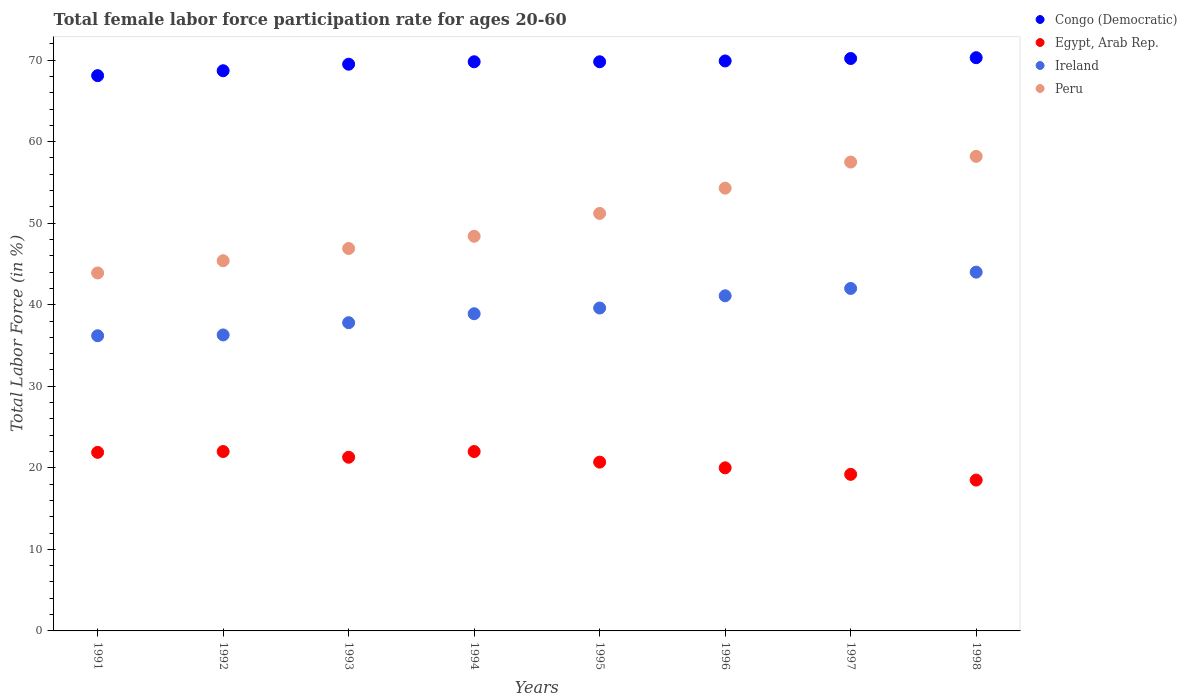How many different coloured dotlines are there?
Make the answer very short. 4. Is the number of dotlines equal to the number of legend labels?
Ensure brevity in your answer.  Yes. What is the female labor force participation rate in Ireland in 1995?
Your answer should be compact. 39.6. Across all years, what is the maximum female labor force participation rate in Congo (Democratic)?
Ensure brevity in your answer.  70.3. Across all years, what is the minimum female labor force participation rate in Congo (Democratic)?
Your response must be concise. 68.1. In which year was the female labor force participation rate in Congo (Democratic) maximum?
Offer a terse response. 1998. In which year was the female labor force participation rate in Congo (Democratic) minimum?
Offer a very short reply. 1991. What is the total female labor force participation rate in Congo (Democratic) in the graph?
Offer a very short reply. 556.3. What is the difference between the female labor force participation rate in Peru in 1993 and that in 1995?
Keep it short and to the point. -4.3. What is the difference between the female labor force participation rate in Ireland in 1991 and the female labor force participation rate in Egypt, Arab Rep. in 1996?
Your answer should be very brief. 16.2. What is the average female labor force participation rate in Egypt, Arab Rep. per year?
Offer a terse response. 20.7. In the year 1994, what is the difference between the female labor force participation rate in Egypt, Arab Rep. and female labor force participation rate in Congo (Democratic)?
Provide a succinct answer. -47.8. In how many years, is the female labor force participation rate in Congo (Democratic) greater than 36 %?
Provide a succinct answer. 8. What is the ratio of the female labor force participation rate in Peru in 1991 to that in 1992?
Offer a terse response. 0.97. Is the female labor force participation rate in Peru in 1993 less than that in 1996?
Your answer should be very brief. Yes. Is the difference between the female labor force participation rate in Egypt, Arab Rep. in 1996 and 1998 greater than the difference between the female labor force participation rate in Congo (Democratic) in 1996 and 1998?
Ensure brevity in your answer.  Yes. Is it the case that in every year, the sum of the female labor force participation rate in Ireland and female labor force participation rate in Egypt, Arab Rep.  is greater than the sum of female labor force participation rate in Congo (Democratic) and female labor force participation rate in Peru?
Ensure brevity in your answer.  No. Is the female labor force participation rate in Congo (Democratic) strictly greater than the female labor force participation rate in Peru over the years?
Make the answer very short. Yes. Is the female labor force participation rate in Ireland strictly less than the female labor force participation rate in Peru over the years?
Offer a very short reply. Yes. How many dotlines are there?
Provide a short and direct response. 4. What is the difference between two consecutive major ticks on the Y-axis?
Your answer should be compact. 10. Are the values on the major ticks of Y-axis written in scientific E-notation?
Give a very brief answer. No. Where does the legend appear in the graph?
Your response must be concise. Top right. What is the title of the graph?
Your answer should be compact. Total female labor force participation rate for ages 20-60. Does "Zimbabwe" appear as one of the legend labels in the graph?
Ensure brevity in your answer.  No. What is the label or title of the X-axis?
Give a very brief answer. Years. What is the label or title of the Y-axis?
Make the answer very short. Total Labor Force (in %). What is the Total Labor Force (in %) of Congo (Democratic) in 1991?
Give a very brief answer. 68.1. What is the Total Labor Force (in %) in Egypt, Arab Rep. in 1991?
Offer a terse response. 21.9. What is the Total Labor Force (in %) of Ireland in 1991?
Keep it short and to the point. 36.2. What is the Total Labor Force (in %) in Peru in 1991?
Give a very brief answer. 43.9. What is the Total Labor Force (in %) in Congo (Democratic) in 1992?
Give a very brief answer. 68.7. What is the Total Labor Force (in %) in Ireland in 1992?
Your response must be concise. 36.3. What is the Total Labor Force (in %) in Peru in 1992?
Provide a succinct answer. 45.4. What is the Total Labor Force (in %) of Congo (Democratic) in 1993?
Your response must be concise. 69.5. What is the Total Labor Force (in %) in Egypt, Arab Rep. in 1993?
Your answer should be compact. 21.3. What is the Total Labor Force (in %) in Ireland in 1993?
Your answer should be compact. 37.8. What is the Total Labor Force (in %) of Peru in 1993?
Your answer should be very brief. 46.9. What is the Total Labor Force (in %) in Congo (Democratic) in 1994?
Provide a succinct answer. 69.8. What is the Total Labor Force (in %) in Egypt, Arab Rep. in 1994?
Give a very brief answer. 22. What is the Total Labor Force (in %) of Ireland in 1994?
Offer a very short reply. 38.9. What is the Total Labor Force (in %) in Peru in 1994?
Ensure brevity in your answer.  48.4. What is the Total Labor Force (in %) of Congo (Democratic) in 1995?
Provide a succinct answer. 69.8. What is the Total Labor Force (in %) of Egypt, Arab Rep. in 1995?
Your answer should be very brief. 20.7. What is the Total Labor Force (in %) in Ireland in 1995?
Make the answer very short. 39.6. What is the Total Labor Force (in %) in Peru in 1995?
Provide a short and direct response. 51.2. What is the Total Labor Force (in %) in Congo (Democratic) in 1996?
Your answer should be compact. 69.9. What is the Total Labor Force (in %) of Egypt, Arab Rep. in 1996?
Give a very brief answer. 20. What is the Total Labor Force (in %) in Ireland in 1996?
Offer a very short reply. 41.1. What is the Total Labor Force (in %) of Peru in 1996?
Provide a succinct answer. 54.3. What is the Total Labor Force (in %) of Congo (Democratic) in 1997?
Keep it short and to the point. 70.2. What is the Total Labor Force (in %) in Egypt, Arab Rep. in 1997?
Provide a short and direct response. 19.2. What is the Total Labor Force (in %) of Peru in 1997?
Provide a short and direct response. 57.5. What is the Total Labor Force (in %) in Congo (Democratic) in 1998?
Your answer should be very brief. 70.3. What is the Total Labor Force (in %) of Ireland in 1998?
Provide a short and direct response. 44. What is the Total Labor Force (in %) in Peru in 1998?
Give a very brief answer. 58.2. Across all years, what is the maximum Total Labor Force (in %) of Congo (Democratic)?
Provide a short and direct response. 70.3. Across all years, what is the maximum Total Labor Force (in %) in Peru?
Give a very brief answer. 58.2. Across all years, what is the minimum Total Labor Force (in %) of Congo (Democratic)?
Your response must be concise. 68.1. Across all years, what is the minimum Total Labor Force (in %) in Ireland?
Your response must be concise. 36.2. Across all years, what is the minimum Total Labor Force (in %) of Peru?
Ensure brevity in your answer.  43.9. What is the total Total Labor Force (in %) in Congo (Democratic) in the graph?
Offer a very short reply. 556.3. What is the total Total Labor Force (in %) in Egypt, Arab Rep. in the graph?
Make the answer very short. 165.6. What is the total Total Labor Force (in %) in Ireland in the graph?
Offer a terse response. 315.9. What is the total Total Labor Force (in %) in Peru in the graph?
Offer a very short reply. 405.8. What is the difference between the Total Labor Force (in %) of Congo (Democratic) in 1991 and that in 1992?
Ensure brevity in your answer.  -0.6. What is the difference between the Total Labor Force (in %) of Egypt, Arab Rep. in 1991 and that in 1992?
Your answer should be compact. -0.1. What is the difference between the Total Labor Force (in %) in Peru in 1991 and that in 1993?
Your answer should be very brief. -3. What is the difference between the Total Labor Force (in %) in Congo (Democratic) in 1991 and that in 1994?
Your response must be concise. -1.7. What is the difference between the Total Labor Force (in %) of Peru in 1991 and that in 1994?
Your response must be concise. -4.5. What is the difference between the Total Labor Force (in %) in Congo (Democratic) in 1991 and that in 1995?
Keep it short and to the point. -1.7. What is the difference between the Total Labor Force (in %) in Egypt, Arab Rep. in 1991 and that in 1995?
Ensure brevity in your answer.  1.2. What is the difference between the Total Labor Force (in %) of Peru in 1991 and that in 1995?
Provide a succinct answer. -7.3. What is the difference between the Total Labor Force (in %) in Congo (Democratic) in 1991 and that in 1996?
Make the answer very short. -1.8. What is the difference between the Total Labor Force (in %) of Ireland in 1991 and that in 1996?
Provide a short and direct response. -4.9. What is the difference between the Total Labor Force (in %) in Peru in 1991 and that in 1996?
Your answer should be very brief. -10.4. What is the difference between the Total Labor Force (in %) of Congo (Democratic) in 1991 and that in 1997?
Give a very brief answer. -2.1. What is the difference between the Total Labor Force (in %) in Egypt, Arab Rep. in 1991 and that in 1997?
Your answer should be compact. 2.7. What is the difference between the Total Labor Force (in %) in Peru in 1991 and that in 1997?
Provide a short and direct response. -13.6. What is the difference between the Total Labor Force (in %) in Egypt, Arab Rep. in 1991 and that in 1998?
Make the answer very short. 3.4. What is the difference between the Total Labor Force (in %) in Ireland in 1991 and that in 1998?
Offer a terse response. -7.8. What is the difference between the Total Labor Force (in %) of Peru in 1991 and that in 1998?
Provide a succinct answer. -14.3. What is the difference between the Total Labor Force (in %) in Congo (Democratic) in 1992 and that in 1993?
Keep it short and to the point. -0.8. What is the difference between the Total Labor Force (in %) of Egypt, Arab Rep. in 1992 and that in 1993?
Provide a short and direct response. 0.7. What is the difference between the Total Labor Force (in %) of Congo (Democratic) in 1992 and that in 1994?
Your answer should be compact. -1.1. What is the difference between the Total Labor Force (in %) in Ireland in 1992 and that in 1994?
Offer a terse response. -2.6. What is the difference between the Total Labor Force (in %) of Congo (Democratic) in 1992 and that in 1995?
Keep it short and to the point. -1.1. What is the difference between the Total Labor Force (in %) of Egypt, Arab Rep. in 1992 and that in 1995?
Your answer should be compact. 1.3. What is the difference between the Total Labor Force (in %) of Ireland in 1992 and that in 1995?
Offer a very short reply. -3.3. What is the difference between the Total Labor Force (in %) of Peru in 1992 and that in 1995?
Keep it short and to the point. -5.8. What is the difference between the Total Labor Force (in %) of Egypt, Arab Rep. in 1992 and that in 1996?
Your answer should be very brief. 2. What is the difference between the Total Labor Force (in %) of Egypt, Arab Rep. in 1992 and that in 1997?
Ensure brevity in your answer.  2.8. What is the difference between the Total Labor Force (in %) of Peru in 1992 and that in 1997?
Offer a very short reply. -12.1. What is the difference between the Total Labor Force (in %) in Egypt, Arab Rep. in 1992 and that in 1998?
Give a very brief answer. 3.5. What is the difference between the Total Labor Force (in %) of Peru in 1992 and that in 1998?
Make the answer very short. -12.8. What is the difference between the Total Labor Force (in %) of Congo (Democratic) in 1993 and that in 1994?
Your answer should be compact. -0.3. What is the difference between the Total Labor Force (in %) in Peru in 1993 and that in 1994?
Make the answer very short. -1.5. What is the difference between the Total Labor Force (in %) in Congo (Democratic) in 1993 and that in 1995?
Your answer should be very brief. -0.3. What is the difference between the Total Labor Force (in %) of Congo (Democratic) in 1993 and that in 1996?
Your response must be concise. -0.4. What is the difference between the Total Labor Force (in %) in Egypt, Arab Rep. in 1993 and that in 1996?
Your response must be concise. 1.3. What is the difference between the Total Labor Force (in %) of Congo (Democratic) in 1993 and that in 1997?
Provide a short and direct response. -0.7. What is the difference between the Total Labor Force (in %) of Egypt, Arab Rep. in 1993 and that in 1997?
Your answer should be compact. 2.1. What is the difference between the Total Labor Force (in %) in Peru in 1993 and that in 1997?
Your answer should be very brief. -10.6. What is the difference between the Total Labor Force (in %) in Congo (Democratic) in 1993 and that in 1998?
Your answer should be compact. -0.8. What is the difference between the Total Labor Force (in %) of Egypt, Arab Rep. in 1993 and that in 1998?
Offer a terse response. 2.8. What is the difference between the Total Labor Force (in %) of Peru in 1993 and that in 1998?
Offer a terse response. -11.3. What is the difference between the Total Labor Force (in %) of Congo (Democratic) in 1994 and that in 1995?
Keep it short and to the point. 0. What is the difference between the Total Labor Force (in %) of Ireland in 1994 and that in 1995?
Keep it short and to the point. -0.7. What is the difference between the Total Labor Force (in %) of Peru in 1994 and that in 1995?
Your response must be concise. -2.8. What is the difference between the Total Labor Force (in %) of Egypt, Arab Rep. in 1994 and that in 1996?
Provide a succinct answer. 2. What is the difference between the Total Labor Force (in %) in Ireland in 1994 and that in 1996?
Your response must be concise. -2.2. What is the difference between the Total Labor Force (in %) in Peru in 1994 and that in 1996?
Give a very brief answer. -5.9. What is the difference between the Total Labor Force (in %) in Congo (Democratic) in 1994 and that in 1997?
Make the answer very short. -0.4. What is the difference between the Total Labor Force (in %) in Egypt, Arab Rep. in 1994 and that in 1997?
Make the answer very short. 2.8. What is the difference between the Total Labor Force (in %) in Peru in 1994 and that in 1997?
Ensure brevity in your answer.  -9.1. What is the difference between the Total Labor Force (in %) of Egypt, Arab Rep. in 1994 and that in 1998?
Ensure brevity in your answer.  3.5. What is the difference between the Total Labor Force (in %) of Ireland in 1994 and that in 1998?
Keep it short and to the point. -5.1. What is the difference between the Total Labor Force (in %) in Egypt, Arab Rep. in 1995 and that in 1997?
Give a very brief answer. 1.5. What is the difference between the Total Labor Force (in %) in Congo (Democratic) in 1995 and that in 1998?
Your answer should be compact. -0.5. What is the difference between the Total Labor Force (in %) in Egypt, Arab Rep. in 1995 and that in 1998?
Provide a succinct answer. 2.2. What is the difference between the Total Labor Force (in %) in Ireland in 1995 and that in 1998?
Ensure brevity in your answer.  -4.4. What is the difference between the Total Labor Force (in %) in Egypt, Arab Rep. in 1996 and that in 1997?
Provide a succinct answer. 0.8. What is the difference between the Total Labor Force (in %) in Ireland in 1996 and that in 1997?
Offer a very short reply. -0.9. What is the difference between the Total Labor Force (in %) in Ireland in 1996 and that in 1998?
Your response must be concise. -2.9. What is the difference between the Total Labor Force (in %) of Peru in 1996 and that in 1998?
Your answer should be compact. -3.9. What is the difference between the Total Labor Force (in %) in Egypt, Arab Rep. in 1997 and that in 1998?
Ensure brevity in your answer.  0.7. What is the difference between the Total Labor Force (in %) of Peru in 1997 and that in 1998?
Offer a terse response. -0.7. What is the difference between the Total Labor Force (in %) of Congo (Democratic) in 1991 and the Total Labor Force (in %) of Egypt, Arab Rep. in 1992?
Ensure brevity in your answer.  46.1. What is the difference between the Total Labor Force (in %) of Congo (Democratic) in 1991 and the Total Labor Force (in %) of Ireland in 1992?
Offer a terse response. 31.8. What is the difference between the Total Labor Force (in %) in Congo (Democratic) in 1991 and the Total Labor Force (in %) in Peru in 1992?
Provide a short and direct response. 22.7. What is the difference between the Total Labor Force (in %) in Egypt, Arab Rep. in 1991 and the Total Labor Force (in %) in Ireland in 1992?
Provide a short and direct response. -14.4. What is the difference between the Total Labor Force (in %) in Egypt, Arab Rep. in 1991 and the Total Labor Force (in %) in Peru in 1992?
Your response must be concise. -23.5. What is the difference between the Total Labor Force (in %) in Ireland in 1991 and the Total Labor Force (in %) in Peru in 1992?
Offer a very short reply. -9.2. What is the difference between the Total Labor Force (in %) of Congo (Democratic) in 1991 and the Total Labor Force (in %) of Egypt, Arab Rep. in 1993?
Your answer should be very brief. 46.8. What is the difference between the Total Labor Force (in %) in Congo (Democratic) in 1991 and the Total Labor Force (in %) in Ireland in 1993?
Make the answer very short. 30.3. What is the difference between the Total Labor Force (in %) of Congo (Democratic) in 1991 and the Total Labor Force (in %) of Peru in 1993?
Offer a terse response. 21.2. What is the difference between the Total Labor Force (in %) of Egypt, Arab Rep. in 1991 and the Total Labor Force (in %) of Ireland in 1993?
Your answer should be very brief. -15.9. What is the difference between the Total Labor Force (in %) in Egypt, Arab Rep. in 1991 and the Total Labor Force (in %) in Peru in 1993?
Offer a very short reply. -25. What is the difference between the Total Labor Force (in %) of Congo (Democratic) in 1991 and the Total Labor Force (in %) of Egypt, Arab Rep. in 1994?
Provide a short and direct response. 46.1. What is the difference between the Total Labor Force (in %) in Congo (Democratic) in 1991 and the Total Labor Force (in %) in Ireland in 1994?
Make the answer very short. 29.2. What is the difference between the Total Labor Force (in %) in Congo (Democratic) in 1991 and the Total Labor Force (in %) in Peru in 1994?
Ensure brevity in your answer.  19.7. What is the difference between the Total Labor Force (in %) of Egypt, Arab Rep. in 1991 and the Total Labor Force (in %) of Peru in 1994?
Give a very brief answer. -26.5. What is the difference between the Total Labor Force (in %) of Ireland in 1991 and the Total Labor Force (in %) of Peru in 1994?
Give a very brief answer. -12.2. What is the difference between the Total Labor Force (in %) of Congo (Democratic) in 1991 and the Total Labor Force (in %) of Egypt, Arab Rep. in 1995?
Make the answer very short. 47.4. What is the difference between the Total Labor Force (in %) of Egypt, Arab Rep. in 1991 and the Total Labor Force (in %) of Ireland in 1995?
Your answer should be very brief. -17.7. What is the difference between the Total Labor Force (in %) of Egypt, Arab Rep. in 1991 and the Total Labor Force (in %) of Peru in 1995?
Ensure brevity in your answer.  -29.3. What is the difference between the Total Labor Force (in %) in Ireland in 1991 and the Total Labor Force (in %) in Peru in 1995?
Give a very brief answer. -15. What is the difference between the Total Labor Force (in %) of Congo (Democratic) in 1991 and the Total Labor Force (in %) of Egypt, Arab Rep. in 1996?
Provide a short and direct response. 48.1. What is the difference between the Total Labor Force (in %) of Congo (Democratic) in 1991 and the Total Labor Force (in %) of Peru in 1996?
Ensure brevity in your answer.  13.8. What is the difference between the Total Labor Force (in %) in Egypt, Arab Rep. in 1991 and the Total Labor Force (in %) in Ireland in 1996?
Your answer should be very brief. -19.2. What is the difference between the Total Labor Force (in %) in Egypt, Arab Rep. in 1991 and the Total Labor Force (in %) in Peru in 1996?
Make the answer very short. -32.4. What is the difference between the Total Labor Force (in %) of Ireland in 1991 and the Total Labor Force (in %) of Peru in 1996?
Make the answer very short. -18.1. What is the difference between the Total Labor Force (in %) of Congo (Democratic) in 1991 and the Total Labor Force (in %) of Egypt, Arab Rep. in 1997?
Offer a terse response. 48.9. What is the difference between the Total Labor Force (in %) in Congo (Democratic) in 1991 and the Total Labor Force (in %) in Ireland in 1997?
Offer a terse response. 26.1. What is the difference between the Total Labor Force (in %) in Egypt, Arab Rep. in 1991 and the Total Labor Force (in %) in Ireland in 1997?
Ensure brevity in your answer.  -20.1. What is the difference between the Total Labor Force (in %) in Egypt, Arab Rep. in 1991 and the Total Labor Force (in %) in Peru in 1997?
Offer a terse response. -35.6. What is the difference between the Total Labor Force (in %) in Ireland in 1991 and the Total Labor Force (in %) in Peru in 1997?
Provide a succinct answer. -21.3. What is the difference between the Total Labor Force (in %) of Congo (Democratic) in 1991 and the Total Labor Force (in %) of Egypt, Arab Rep. in 1998?
Make the answer very short. 49.6. What is the difference between the Total Labor Force (in %) of Congo (Democratic) in 1991 and the Total Labor Force (in %) of Ireland in 1998?
Provide a short and direct response. 24.1. What is the difference between the Total Labor Force (in %) of Egypt, Arab Rep. in 1991 and the Total Labor Force (in %) of Ireland in 1998?
Offer a terse response. -22.1. What is the difference between the Total Labor Force (in %) of Egypt, Arab Rep. in 1991 and the Total Labor Force (in %) of Peru in 1998?
Provide a short and direct response. -36.3. What is the difference between the Total Labor Force (in %) in Congo (Democratic) in 1992 and the Total Labor Force (in %) in Egypt, Arab Rep. in 1993?
Give a very brief answer. 47.4. What is the difference between the Total Labor Force (in %) in Congo (Democratic) in 1992 and the Total Labor Force (in %) in Ireland in 1993?
Provide a succinct answer. 30.9. What is the difference between the Total Labor Force (in %) in Congo (Democratic) in 1992 and the Total Labor Force (in %) in Peru in 1993?
Keep it short and to the point. 21.8. What is the difference between the Total Labor Force (in %) in Egypt, Arab Rep. in 1992 and the Total Labor Force (in %) in Ireland in 1993?
Keep it short and to the point. -15.8. What is the difference between the Total Labor Force (in %) of Egypt, Arab Rep. in 1992 and the Total Labor Force (in %) of Peru in 1993?
Your answer should be very brief. -24.9. What is the difference between the Total Labor Force (in %) of Ireland in 1992 and the Total Labor Force (in %) of Peru in 1993?
Your answer should be compact. -10.6. What is the difference between the Total Labor Force (in %) of Congo (Democratic) in 1992 and the Total Labor Force (in %) of Egypt, Arab Rep. in 1994?
Provide a succinct answer. 46.7. What is the difference between the Total Labor Force (in %) of Congo (Democratic) in 1992 and the Total Labor Force (in %) of Ireland in 1994?
Make the answer very short. 29.8. What is the difference between the Total Labor Force (in %) of Congo (Democratic) in 1992 and the Total Labor Force (in %) of Peru in 1994?
Provide a short and direct response. 20.3. What is the difference between the Total Labor Force (in %) in Egypt, Arab Rep. in 1992 and the Total Labor Force (in %) in Ireland in 1994?
Offer a very short reply. -16.9. What is the difference between the Total Labor Force (in %) in Egypt, Arab Rep. in 1992 and the Total Labor Force (in %) in Peru in 1994?
Keep it short and to the point. -26.4. What is the difference between the Total Labor Force (in %) of Ireland in 1992 and the Total Labor Force (in %) of Peru in 1994?
Your answer should be very brief. -12.1. What is the difference between the Total Labor Force (in %) of Congo (Democratic) in 1992 and the Total Labor Force (in %) of Ireland in 1995?
Give a very brief answer. 29.1. What is the difference between the Total Labor Force (in %) in Egypt, Arab Rep. in 1992 and the Total Labor Force (in %) in Ireland in 1995?
Make the answer very short. -17.6. What is the difference between the Total Labor Force (in %) of Egypt, Arab Rep. in 1992 and the Total Labor Force (in %) of Peru in 1995?
Your answer should be very brief. -29.2. What is the difference between the Total Labor Force (in %) in Ireland in 1992 and the Total Labor Force (in %) in Peru in 1995?
Your answer should be very brief. -14.9. What is the difference between the Total Labor Force (in %) in Congo (Democratic) in 1992 and the Total Labor Force (in %) in Egypt, Arab Rep. in 1996?
Give a very brief answer. 48.7. What is the difference between the Total Labor Force (in %) in Congo (Democratic) in 1992 and the Total Labor Force (in %) in Ireland in 1996?
Provide a short and direct response. 27.6. What is the difference between the Total Labor Force (in %) in Egypt, Arab Rep. in 1992 and the Total Labor Force (in %) in Ireland in 1996?
Your response must be concise. -19.1. What is the difference between the Total Labor Force (in %) in Egypt, Arab Rep. in 1992 and the Total Labor Force (in %) in Peru in 1996?
Ensure brevity in your answer.  -32.3. What is the difference between the Total Labor Force (in %) of Ireland in 1992 and the Total Labor Force (in %) of Peru in 1996?
Give a very brief answer. -18. What is the difference between the Total Labor Force (in %) in Congo (Democratic) in 1992 and the Total Labor Force (in %) in Egypt, Arab Rep. in 1997?
Ensure brevity in your answer.  49.5. What is the difference between the Total Labor Force (in %) in Congo (Democratic) in 1992 and the Total Labor Force (in %) in Ireland in 1997?
Offer a terse response. 26.7. What is the difference between the Total Labor Force (in %) in Congo (Democratic) in 1992 and the Total Labor Force (in %) in Peru in 1997?
Your answer should be very brief. 11.2. What is the difference between the Total Labor Force (in %) in Egypt, Arab Rep. in 1992 and the Total Labor Force (in %) in Peru in 1997?
Provide a short and direct response. -35.5. What is the difference between the Total Labor Force (in %) of Ireland in 1992 and the Total Labor Force (in %) of Peru in 1997?
Provide a short and direct response. -21.2. What is the difference between the Total Labor Force (in %) of Congo (Democratic) in 1992 and the Total Labor Force (in %) of Egypt, Arab Rep. in 1998?
Give a very brief answer. 50.2. What is the difference between the Total Labor Force (in %) in Congo (Democratic) in 1992 and the Total Labor Force (in %) in Ireland in 1998?
Provide a succinct answer. 24.7. What is the difference between the Total Labor Force (in %) of Egypt, Arab Rep. in 1992 and the Total Labor Force (in %) of Ireland in 1998?
Your answer should be compact. -22. What is the difference between the Total Labor Force (in %) of Egypt, Arab Rep. in 1992 and the Total Labor Force (in %) of Peru in 1998?
Your response must be concise. -36.2. What is the difference between the Total Labor Force (in %) of Ireland in 1992 and the Total Labor Force (in %) of Peru in 1998?
Offer a terse response. -21.9. What is the difference between the Total Labor Force (in %) of Congo (Democratic) in 1993 and the Total Labor Force (in %) of Egypt, Arab Rep. in 1994?
Provide a succinct answer. 47.5. What is the difference between the Total Labor Force (in %) in Congo (Democratic) in 1993 and the Total Labor Force (in %) in Ireland in 1994?
Make the answer very short. 30.6. What is the difference between the Total Labor Force (in %) in Congo (Democratic) in 1993 and the Total Labor Force (in %) in Peru in 1994?
Offer a very short reply. 21.1. What is the difference between the Total Labor Force (in %) in Egypt, Arab Rep. in 1993 and the Total Labor Force (in %) in Ireland in 1994?
Give a very brief answer. -17.6. What is the difference between the Total Labor Force (in %) of Egypt, Arab Rep. in 1993 and the Total Labor Force (in %) of Peru in 1994?
Offer a very short reply. -27.1. What is the difference between the Total Labor Force (in %) in Congo (Democratic) in 1993 and the Total Labor Force (in %) in Egypt, Arab Rep. in 1995?
Provide a short and direct response. 48.8. What is the difference between the Total Labor Force (in %) of Congo (Democratic) in 1993 and the Total Labor Force (in %) of Ireland in 1995?
Provide a succinct answer. 29.9. What is the difference between the Total Labor Force (in %) in Egypt, Arab Rep. in 1993 and the Total Labor Force (in %) in Ireland in 1995?
Your answer should be very brief. -18.3. What is the difference between the Total Labor Force (in %) in Egypt, Arab Rep. in 1993 and the Total Labor Force (in %) in Peru in 1995?
Ensure brevity in your answer.  -29.9. What is the difference between the Total Labor Force (in %) of Ireland in 1993 and the Total Labor Force (in %) of Peru in 1995?
Offer a very short reply. -13.4. What is the difference between the Total Labor Force (in %) in Congo (Democratic) in 1993 and the Total Labor Force (in %) in Egypt, Arab Rep. in 1996?
Offer a very short reply. 49.5. What is the difference between the Total Labor Force (in %) in Congo (Democratic) in 1993 and the Total Labor Force (in %) in Ireland in 1996?
Your answer should be very brief. 28.4. What is the difference between the Total Labor Force (in %) of Congo (Democratic) in 1993 and the Total Labor Force (in %) of Peru in 1996?
Offer a terse response. 15.2. What is the difference between the Total Labor Force (in %) of Egypt, Arab Rep. in 1993 and the Total Labor Force (in %) of Ireland in 1996?
Keep it short and to the point. -19.8. What is the difference between the Total Labor Force (in %) of Egypt, Arab Rep. in 1993 and the Total Labor Force (in %) of Peru in 1996?
Your answer should be very brief. -33. What is the difference between the Total Labor Force (in %) in Ireland in 1993 and the Total Labor Force (in %) in Peru in 1996?
Ensure brevity in your answer.  -16.5. What is the difference between the Total Labor Force (in %) of Congo (Democratic) in 1993 and the Total Labor Force (in %) of Egypt, Arab Rep. in 1997?
Offer a terse response. 50.3. What is the difference between the Total Labor Force (in %) in Congo (Democratic) in 1993 and the Total Labor Force (in %) in Ireland in 1997?
Provide a succinct answer. 27.5. What is the difference between the Total Labor Force (in %) in Congo (Democratic) in 1993 and the Total Labor Force (in %) in Peru in 1997?
Your answer should be compact. 12. What is the difference between the Total Labor Force (in %) in Egypt, Arab Rep. in 1993 and the Total Labor Force (in %) in Ireland in 1997?
Make the answer very short. -20.7. What is the difference between the Total Labor Force (in %) in Egypt, Arab Rep. in 1993 and the Total Labor Force (in %) in Peru in 1997?
Provide a short and direct response. -36.2. What is the difference between the Total Labor Force (in %) in Ireland in 1993 and the Total Labor Force (in %) in Peru in 1997?
Give a very brief answer. -19.7. What is the difference between the Total Labor Force (in %) of Congo (Democratic) in 1993 and the Total Labor Force (in %) of Egypt, Arab Rep. in 1998?
Ensure brevity in your answer.  51. What is the difference between the Total Labor Force (in %) in Congo (Democratic) in 1993 and the Total Labor Force (in %) in Ireland in 1998?
Your response must be concise. 25.5. What is the difference between the Total Labor Force (in %) of Egypt, Arab Rep. in 1993 and the Total Labor Force (in %) of Ireland in 1998?
Ensure brevity in your answer.  -22.7. What is the difference between the Total Labor Force (in %) of Egypt, Arab Rep. in 1993 and the Total Labor Force (in %) of Peru in 1998?
Ensure brevity in your answer.  -36.9. What is the difference between the Total Labor Force (in %) of Ireland in 1993 and the Total Labor Force (in %) of Peru in 1998?
Keep it short and to the point. -20.4. What is the difference between the Total Labor Force (in %) in Congo (Democratic) in 1994 and the Total Labor Force (in %) in Egypt, Arab Rep. in 1995?
Your answer should be compact. 49.1. What is the difference between the Total Labor Force (in %) of Congo (Democratic) in 1994 and the Total Labor Force (in %) of Ireland in 1995?
Keep it short and to the point. 30.2. What is the difference between the Total Labor Force (in %) in Congo (Democratic) in 1994 and the Total Labor Force (in %) in Peru in 1995?
Offer a terse response. 18.6. What is the difference between the Total Labor Force (in %) of Egypt, Arab Rep. in 1994 and the Total Labor Force (in %) of Ireland in 1995?
Your response must be concise. -17.6. What is the difference between the Total Labor Force (in %) in Egypt, Arab Rep. in 1994 and the Total Labor Force (in %) in Peru in 1995?
Keep it short and to the point. -29.2. What is the difference between the Total Labor Force (in %) of Ireland in 1994 and the Total Labor Force (in %) of Peru in 1995?
Give a very brief answer. -12.3. What is the difference between the Total Labor Force (in %) in Congo (Democratic) in 1994 and the Total Labor Force (in %) in Egypt, Arab Rep. in 1996?
Ensure brevity in your answer.  49.8. What is the difference between the Total Labor Force (in %) in Congo (Democratic) in 1994 and the Total Labor Force (in %) in Ireland in 1996?
Give a very brief answer. 28.7. What is the difference between the Total Labor Force (in %) of Congo (Democratic) in 1994 and the Total Labor Force (in %) of Peru in 1996?
Your answer should be very brief. 15.5. What is the difference between the Total Labor Force (in %) of Egypt, Arab Rep. in 1994 and the Total Labor Force (in %) of Ireland in 1996?
Offer a terse response. -19.1. What is the difference between the Total Labor Force (in %) of Egypt, Arab Rep. in 1994 and the Total Labor Force (in %) of Peru in 1996?
Ensure brevity in your answer.  -32.3. What is the difference between the Total Labor Force (in %) in Ireland in 1994 and the Total Labor Force (in %) in Peru in 1996?
Your answer should be compact. -15.4. What is the difference between the Total Labor Force (in %) of Congo (Democratic) in 1994 and the Total Labor Force (in %) of Egypt, Arab Rep. in 1997?
Make the answer very short. 50.6. What is the difference between the Total Labor Force (in %) of Congo (Democratic) in 1994 and the Total Labor Force (in %) of Ireland in 1997?
Ensure brevity in your answer.  27.8. What is the difference between the Total Labor Force (in %) of Egypt, Arab Rep. in 1994 and the Total Labor Force (in %) of Ireland in 1997?
Your answer should be very brief. -20. What is the difference between the Total Labor Force (in %) in Egypt, Arab Rep. in 1994 and the Total Labor Force (in %) in Peru in 1997?
Provide a short and direct response. -35.5. What is the difference between the Total Labor Force (in %) in Ireland in 1994 and the Total Labor Force (in %) in Peru in 1997?
Ensure brevity in your answer.  -18.6. What is the difference between the Total Labor Force (in %) in Congo (Democratic) in 1994 and the Total Labor Force (in %) in Egypt, Arab Rep. in 1998?
Your response must be concise. 51.3. What is the difference between the Total Labor Force (in %) of Congo (Democratic) in 1994 and the Total Labor Force (in %) of Ireland in 1998?
Offer a terse response. 25.8. What is the difference between the Total Labor Force (in %) of Congo (Democratic) in 1994 and the Total Labor Force (in %) of Peru in 1998?
Provide a succinct answer. 11.6. What is the difference between the Total Labor Force (in %) of Egypt, Arab Rep. in 1994 and the Total Labor Force (in %) of Ireland in 1998?
Offer a very short reply. -22. What is the difference between the Total Labor Force (in %) of Egypt, Arab Rep. in 1994 and the Total Labor Force (in %) of Peru in 1998?
Your answer should be compact. -36.2. What is the difference between the Total Labor Force (in %) of Ireland in 1994 and the Total Labor Force (in %) of Peru in 1998?
Your answer should be very brief. -19.3. What is the difference between the Total Labor Force (in %) in Congo (Democratic) in 1995 and the Total Labor Force (in %) in Egypt, Arab Rep. in 1996?
Offer a very short reply. 49.8. What is the difference between the Total Labor Force (in %) of Congo (Democratic) in 1995 and the Total Labor Force (in %) of Ireland in 1996?
Provide a short and direct response. 28.7. What is the difference between the Total Labor Force (in %) in Congo (Democratic) in 1995 and the Total Labor Force (in %) in Peru in 1996?
Your response must be concise. 15.5. What is the difference between the Total Labor Force (in %) in Egypt, Arab Rep. in 1995 and the Total Labor Force (in %) in Ireland in 1996?
Offer a terse response. -20.4. What is the difference between the Total Labor Force (in %) in Egypt, Arab Rep. in 1995 and the Total Labor Force (in %) in Peru in 1996?
Make the answer very short. -33.6. What is the difference between the Total Labor Force (in %) in Ireland in 1995 and the Total Labor Force (in %) in Peru in 1996?
Provide a short and direct response. -14.7. What is the difference between the Total Labor Force (in %) of Congo (Democratic) in 1995 and the Total Labor Force (in %) of Egypt, Arab Rep. in 1997?
Give a very brief answer. 50.6. What is the difference between the Total Labor Force (in %) of Congo (Democratic) in 1995 and the Total Labor Force (in %) of Ireland in 1997?
Offer a terse response. 27.8. What is the difference between the Total Labor Force (in %) of Egypt, Arab Rep. in 1995 and the Total Labor Force (in %) of Ireland in 1997?
Provide a short and direct response. -21.3. What is the difference between the Total Labor Force (in %) of Egypt, Arab Rep. in 1995 and the Total Labor Force (in %) of Peru in 1997?
Provide a short and direct response. -36.8. What is the difference between the Total Labor Force (in %) in Ireland in 1995 and the Total Labor Force (in %) in Peru in 1997?
Make the answer very short. -17.9. What is the difference between the Total Labor Force (in %) of Congo (Democratic) in 1995 and the Total Labor Force (in %) of Egypt, Arab Rep. in 1998?
Give a very brief answer. 51.3. What is the difference between the Total Labor Force (in %) of Congo (Democratic) in 1995 and the Total Labor Force (in %) of Ireland in 1998?
Your response must be concise. 25.8. What is the difference between the Total Labor Force (in %) in Egypt, Arab Rep. in 1995 and the Total Labor Force (in %) in Ireland in 1998?
Your response must be concise. -23.3. What is the difference between the Total Labor Force (in %) in Egypt, Arab Rep. in 1995 and the Total Labor Force (in %) in Peru in 1998?
Ensure brevity in your answer.  -37.5. What is the difference between the Total Labor Force (in %) of Ireland in 1995 and the Total Labor Force (in %) of Peru in 1998?
Ensure brevity in your answer.  -18.6. What is the difference between the Total Labor Force (in %) of Congo (Democratic) in 1996 and the Total Labor Force (in %) of Egypt, Arab Rep. in 1997?
Your response must be concise. 50.7. What is the difference between the Total Labor Force (in %) in Congo (Democratic) in 1996 and the Total Labor Force (in %) in Ireland in 1997?
Your answer should be very brief. 27.9. What is the difference between the Total Labor Force (in %) of Egypt, Arab Rep. in 1996 and the Total Labor Force (in %) of Peru in 1997?
Offer a terse response. -37.5. What is the difference between the Total Labor Force (in %) in Ireland in 1996 and the Total Labor Force (in %) in Peru in 1997?
Your response must be concise. -16.4. What is the difference between the Total Labor Force (in %) in Congo (Democratic) in 1996 and the Total Labor Force (in %) in Egypt, Arab Rep. in 1998?
Keep it short and to the point. 51.4. What is the difference between the Total Labor Force (in %) of Congo (Democratic) in 1996 and the Total Labor Force (in %) of Ireland in 1998?
Your answer should be compact. 25.9. What is the difference between the Total Labor Force (in %) in Egypt, Arab Rep. in 1996 and the Total Labor Force (in %) in Peru in 1998?
Your answer should be very brief. -38.2. What is the difference between the Total Labor Force (in %) of Ireland in 1996 and the Total Labor Force (in %) of Peru in 1998?
Provide a succinct answer. -17.1. What is the difference between the Total Labor Force (in %) in Congo (Democratic) in 1997 and the Total Labor Force (in %) in Egypt, Arab Rep. in 1998?
Your answer should be compact. 51.7. What is the difference between the Total Labor Force (in %) of Congo (Democratic) in 1997 and the Total Labor Force (in %) of Ireland in 1998?
Give a very brief answer. 26.2. What is the difference between the Total Labor Force (in %) of Egypt, Arab Rep. in 1997 and the Total Labor Force (in %) of Ireland in 1998?
Provide a short and direct response. -24.8. What is the difference between the Total Labor Force (in %) of Egypt, Arab Rep. in 1997 and the Total Labor Force (in %) of Peru in 1998?
Make the answer very short. -39. What is the difference between the Total Labor Force (in %) in Ireland in 1997 and the Total Labor Force (in %) in Peru in 1998?
Ensure brevity in your answer.  -16.2. What is the average Total Labor Force (in %) of Congo (Democratic) per year?
Offer a terse response. 69.54. What is the average Total Labor Force (in %) of Egypt, Arab Rep. per year?
Ensure brevity in your answer.  20.7. What is the average Total Labor Force (in %) of Ireland per year?
Keep it short and to the point. 39.49. What is the average Total Labor Force (in %) in Peru per year?
Give a very brief answer. 50.73. In the year 1991, what is the difference between the Total Labor Force (in %) in Congo (Democratic) and Total Labor Force (in %) in Egypt, Arab Rep.?
Your answer should be compact. 46.2. In the year 1991, what is the difference between the Total Labor Force (in %) of Congo (Democratic) and Total Labor Force (in %) of Ireland?
Make the answer very short. 31.9. In the year 1991, what is the difference between the Total Labor Force (in %) in Congo (Democratic) and Total Labor Force (in %) in Peru?
Provide a short and direct response. 24.2. In the year 1991, what is the difference between the Total Labor Force (in %) of Egypt, Arab Rep. and Total Labor Force (in %) of Ireland?
Keep it short and to the point. -14.3. In the year 1991, what is the difference between the Total Labor Force (in %) in Egypt, Arab Rep. and Total Labor Force (in %) in Peru?
Your answer should be very brief. -22. In the year 1991, what is the difference between the Total Labor Force (in %) of Ireland and Total Labor Force (in %) of Peru?
Your answer should be very brief. -7.7. In the year 1992, what is the difference between the Total Labor Force (in %) in Congo (Democratic) and Total Labor Force (in %) in Egypt, Arab Rep.?
Ensure brevity in your answer.  46.7. In the year 1992, what is the difference between the Total Labor Force (in %) of Congo (Democratic) and Total Labor Force (in %) of Ireland?
Offer a terse response. 32.4. In the year 1992, what is the difference between the Total Labor Force (in %) in Congo (Democratic) and Total Labor Force (in %) in Peru?
Offer a very short reply. 23.3. In the year 1992, what is the difference between the Total Labor Force (in %) of Egypt, Arab Rep. and Total Labor Force (in %) of Ireland?
Ensure brevity in your answer.  -14.3. In the year 1992, what is the difference between the Total Labor Force (in %) in Egypt, Arab Rep. and Total Labor Force (in %) in Peru?
Offer a very short reply. -23.4. In the year 1993, what is the difference between the Total Labor Force (in %) in Congo (Democratic) and Total Labor Force (in %) in Egypt, Arab Rep.?
Keep it short and to the point. 48.2. In the year 1993, what is the difference between the Total Labor Force (in %) in Congo (Democratic) and Total Labor Force (in %) in Ireland?
Keep it short and to the point. 31.7. In the year 1993, what is the difference between the Total Labor Force (in %) of Congo (Democratic) and Total Labor Force (in %) of Peru?
Provide a succinct answer. 22.6. In the year 1993, what is the difference between the Total Labor Force (in %) of Egypt, Arab Rep. and Total Labor Force (in %) of Ireland?
Provide a short and direct response. -16.5. In the year 1993, what is the difference between the Total Labor Force (in %) in Egypt, Arab Rep. and Total Labor Force (in %) in Peru?
Make the answer very short. -25.6. In the year 1994, what is the difference between the Total Labor Force (in %) in Congo (Democratic) and Total Labor Force (in %) in Egypt, Arab Rep.?
Keep it short and to the point. 47.8. In the year 1994, what is the difference between the Total Labor Force (in %) in Congo (Democratic) and Total Labor Force (in %) in Ireland?
Give a very brief answer. 30.9. In the year 1994, what is the difference between the Total Labor Force (in %) in Congo (Democratic) and Total Labor Force (in %) in Peru?
Make the answer very short. 21.4. In the year 1994, what is the difference between the Total Labor Force (in %) of Egypt, Arab Rep. and Total Labor Force (in %) of Ireland?
Your response must be concise. -16.9. In the year 1994, what is the difference between the Total Labor Force (in %) in Egypt, Arab Rep. and Total Labor Force (in %) in Peru?
Make the answer very short. -26.4. In the year 1994, what is the difference between the Total Labor Force (in %) in Ireland and Total Labor Force (in %) in Peru?
Your answer should be very brief. -9.5. In the year 1995, what is the difference between the Total Labor Force (in %) in Congo (Democratic) and Total Labor Force (in %) in Egypt, Arab Rep.?
Give a very brief answer. 49.1. In the year 1995, what is the difference between the Total Labor Force (in %) in Congo (Democratic) and Total Labor Force (in %) in Ireland?
Provide a succinct answer. 30.2. In the year 1995, what is the difference between the Total Labor Force (in %) of Congo (Democratic) and Total Labor Force (in %) of Peru?
Make the answer very short. 18.6. In the year 1995, what is the difference between the Total Labor Force (in %) of Egypt, Arab Rep. and Total Labor Force (in %) of Ireland?
Your response must be concise. -18.9. In the year 1995, what is the difference between the Total Labor Force (in %) in Egypt, Arab Rep. and Total Labor Force (in %) in Peru?
Your response must be concise. -30.5. In the year 1995, what is the difference between the Total Labor Force (in %) of Ireland and Total Labor Force (in %) of Peru?
Give a very brief answer. -11.6. In the year 1996, what is the difference between the Total Labor Force (in %) in Congo (Democratic) and Total Labor Force (in %) in Egypt, Arab Rep.?
Your response must be concise. 49.9. In the year 1996, what is the difference between the Total Labor Force (in %) of Congo (Democratic) and Total Labor Force (in %) of Ireland?
Keep it short and to the point. 28.8. In the year 1996, what is the difference between the Total Labor Force (in %) in Congo (Democratic) and Total Labor Force (in %) in Peru?
Offer a terse response. 15.6. In the year 1996, what is the difference between the Total Labor Force (in %) in Egypt, Arab Rep. and Total Labor Force (in %) in Ireland?
Offer a terse response. -21.1. In the year 1996, what is the difference between the Total Labor Force (in %) of Egypt, Arab Rep. and Total Labor Force (in %) of Peru?
Your answer should be compact. -34.3. In the year 1997, what is the difference between the Total Labor Force (in %) of Congo (Democratic) and Total Labor Force (in %) of Ireland?
Make the answer very short. 28.2. In the year 1997, what is the difference between the Total Labor Force (in %) in Congo (Democratic) and Total Labor Force (in %) in Peru?
Make the answer very short. 12.7. In the year 1997, what is the difference between the Total Labor Force (in %) of Egypt, Arab Rep. and Total Labor Force (in %) of Ireland?
Your answer should be compact. -22.8. In the year 1997, what is the difference between the Total Labor Force (in %) in Egypt, Arab Rep. and Total Labor Force (in %) in Peru?
Make the answer very short. -38.3. In the year 1997, what is the difference between the Total Labor Force (in %) in Ireland and Total Labor Force (in %) in Peru?
Provide a succinct answer. -15.5. In the year 1998, what is the difference between the Total Labor Force (in %) of Congo (Democratic) and Total Labor Force (in %) of Egypt, Arab Rep.?
Make the answer very short. 51.8. In the year 1998, what is the difference between the Total Labor Force (in %) in Congo (Democratic) and Total Labor Force (in %) in Ireland?
Offer a very short reply. 26.3. In the year 1998, what is the difference between the Total Labor Force (in %) in Congo (Democratic) and Total Labor Force (in %) in Peru?
Your answer should be compact. 12.1. In the year 1998, what is the difference between the Total Labor Force (in %) of Egypt, Arab Rep. and Total Labor Force (in %) of Ireland?
Provide a short and direct response. -25.5. In the year 1998, what is the difference between the Total Labor Force (in %) of Egypt, Arab Rep. and Total Labor Force (in %) of Peru?
Your answer should be compact. -39.7. In the year 1998, what is the difference between the Total Labor Force (in %) in Ireland and Total Labor Force (in %) in Peru?
Provide a succinct answer. -14.2. What is the ratio of the Total Labor Force (in %) of Congo (Democratic) in 1991 to that in 1992?
Offer a very short reply. 0.99. What is the ratio of the Total Labor Force (in %) of Egypt, Arab Rep. in 1991 to that in 1992?
Your answer should be compact. 1. What is the ratio of the Total Labor Force (in %) in Ireland in 1991 to that in 1992?
Keep it short and to the point. 1. What is the ratio of the Total Labor Force (in %) in Peru in 1991 to that in 1992?
Provide a short and direct response. 0.97. What is the ratio of the Total Labor Force (in %) in Congo (Democratic) in 1991 to that in 1993?
Provide a succinct answer. 0.98. What is the ratio of the Total Labor Force (in %) in Egypt, Arab Rep. in 1991 to that in 1993?
Your answer should be compact. 1.03. What is the ratio of the Total Labor Force (in %) of Ireland in 1991 to that in 1993?
Keep it short and to the point. 0.96. What is the ratio of the Total Labor Force (in %) in Peru in 1991 to that in 1993?
Your answer should be compact. 0.94. What is the ratio of the Total Labor Force (in %) of Congo (Democratic) in 1991 to that in 1994?
Give a very brief answer. 0.98. What is the ratio of the Total Labor Force (in %) of Ireland in 1991 to that in 1994?
Ensure brevity in your answer.  0.93. What is the ratio of the Total Labor Force (in %) of Peru in 1991 to that in 1994?
Your answer should be compact. 0.91. What is the ratio of the Total Labor Force (in %) of Congo (Democratic) in 1991 to that in 1995?
Give a very brief answer. 0.98. What is the ratio of the Total Labor Force (in %) of Egypt, Arab Rep. in 1991 to that in 1995?
Ensure brevity in your answer.  1.06. What is the ratio of the Total Labor Force (in %) in Ireland in 1991 to that in 1995?
Ensure brevity in your answer.  0.91. What is the ratio of the Total Labor Force (in %) of Peru in 1991 to that in 1995?
Ensure brevity in your answer.  0.86. What is the ratio of the Total Labor Force (in %) in Congo (Democratic) in 1991 to that in 1996?
Give a very brief answer. 0.97. What is the ratio of the Total Labor Force (in %) of Egypt, Arab Rep. in 1991 to that in 1996?
Your answer should be very brief. 1.09. What is the ratio of the Total Labor Force (in %) of Ireland in 1991 to that in 1996?
Offer a very short reply. 0.88. What is the ratio of the Total Labor Force (in %) in Peru in 1991 to that in 1996?
Keep it short and to the point. 0.81. What is the ratio of the Total Labor Force (in %) of Congo (Democratic) in 1991 to that in 1997?
Provide a succinct answer. 0.97. What is the ratio of the Total Labor Force (in %) in Egypt, Arab Rep. in 1991 to that in 1997?
Provide a short and direct response. 1.14. What is the ratio of the Total Labor Force (in %) of Ireland in 1991 to that in 1997?
Your answer should be very brief. 0.86. What is the ratio of the Total Labor Force (in %) of Peru in 1991 to that in 1997?
Make the answer very short. 0.76. What is the ratio of the Total Labor Force (in %) in Congo (Democratic) in 1991 to that in 1998?
Keep it short and to the point. 0.97. What is the ratio of the Total Labor Force (in %) of Egypt, Arab Rep. in 1991 to that in 1998?
Your answer should be compact. 1.18. What is the ratio of the Total Labor Force (in %) of Ireland in 1991 to that in 1998?
Your answer should be compact. 0.82. What is the ratio of the Total Labor Force (in %) in Peru in 1991 to that in 1998?
Provide a short and direct response. 0.75. What is the ratio of the Total Labor Force (in %) in Congo (Democratic) in 1992 to that in 1993?
Offer a terse response. 0.99. What is the ratio of the Total Labor Force (in %) in Egypt, Arab Rep. in 1992 to that in 1993?
Ensure brevity in your answer.  1.03. What is the ratio of the Total Labor Force (in %) of Ireland in 1992 to that in 1993?
Offer a very short reply. 0.96. What is the ratio of the Total Labor Force (in %) in Congo (Democratic) in 1992 to that in 1994?
Ensure brevity in your answer.  0.98. What is the ratio of the Total Labor Force (in %) of Ireland in 1992 to that in 1994?
Offer a terse response. 0.93. What is the ratio of the Total Labor Force (in %) of Peru in 1992 to that in 1994?
Offer a terse response. 0.94. What is the ratio of the Total Labor Force (in %) of Congo (Democratic) in 1992 to that in 1995?
Provide a short and direct response. 0.98. What is the ratio of the Total Labor Force (in %) in Egypt, Arab Rep. in 1992 to that in 1995?
Provide a succinct answer. 1.06. What is the ratio of the Total Labor Force (in %) of Peru in 1992 to that in 1995?
Make the answer very short. 0.89. What is the ratio of the Total Labor Force (in %) of Congo (Democratic) in 1992 to that in 1996?
Your response must be concise. 0.98. What is the ratio of the Total Labor Force (in %) in Ireland in 1992 to that in 1996?
Your answer should be very brief. 0.88. What is the ratio of the Total Labor Force (in %) in Peru in 1992 to that in 1996?
Your answer should be very brief. 0.84. What is the ratio of the Total Labor Force (in %) of Congo (Democratic) in 1992 to that in 1997?
Offer a very short reply. 0.98. What is the ratio of the Total Labor Force (in %) of Egypt, Arab Rep. in 1992 to that in 1997?
Your response must be concise. 1.15. What is the ratio of the Total Labor Force (in %) of Ireland in 1992 to that in 1997?
Your response must be concise. 0.86. What is the ratio of the Total Labor Force (in %) of Peru in 1992 to that in 1997?
Ensure brevity in your answer.  0.79. What is the ratio of the Total Labor Force (in %) of Congo (Democratic) in 1992 to that in 1998?
Your answer should be compact. 0.98. What is the ratio of the Total Labor Force (in %) of Egypt, Arab Rep. in 1992 to that in 1998?
Your answer should be compact. 1.19. What is the ratio of the Total Labor Force (in %) in Ireland in 1992 to that in 1998?
Your response must be concise. 0.82. What is the ratio of the Total Labor Force (in %) in Peru in 1992 to that in 1998?
Provide a short and direct response. 0.78. What is the ratio of the Total Labor Force (in %) in Egypt, Arab Rep. in 1993 to that in 1994?
Keep it short and to the point. 0.97. What is the ratio of the Total Labor Force (in %) in Ireland in 1993 to that in 1994?
Keep it short and to the point. 0.97. What is the ratio of the Total Labor Force (in %) of Ireland in 1993 to that in 1995?
Offer a terse response. 0.95. What is the ratio of the Total Labor Force (in %) of Peru in 1993 to that in 1995?
Offer a terse response. 0.92. What is the ratio of the Total Labor Force (in %) in Congo (Democratic) in 1993 to that in 1996?
Your answer should be very brief. 0.99. What is the ratio of the Total Labor Force (in %) of Egypt, Arab Rep. in 1993 to that in 1996?
Make the answer very short. 1.06. What is the ratio of the Total Labor Force (in %) in Ireland in 1993 to that in 1996?
Make the answer very short. 0.92. What is the ratio of the Total Labor Force (in %) of Peru in 1993 to that in 1996?
Give a very brief answer. 0.86. What is the ratio of the Total Labor Force (in %) in Congo (Democratic) in 1993 to that in 1997?
Your response must be concise. 0.99. What is the ratio of the Total Labor Force (in %) in Egypt, Arab Rep. in 1993 to that in 1997?
Make the answer very short. 1.11. What is the ratio of the Total Labor Force (in %) in Ireland in 1993 to that in 1997?
Your answer should be compact. 0.9. What is the ratio of the Total Labor Force (in %) of Peru in 1993 to that in 1997?
Give a very brief answer. 0.82. What is the ratio of the Total Labor Force (in %) of Egypt, Arab Rep. in 1993 to that in 1998?
Ensure brevity in your answer.  1.15. What is the ratio of the Total Labor Force (in %) of Ireland in 1993 to that in 1998?
Offer a very short reply. 0.86. What is the ratio of the Total Labor Force (in %) of Peru in 1993 to that in 1998?
Give a very brief answer. 0.81. What is the ratio of the Total Labor Force (in %) in Egypt, Arab Rep. in 1994 to that in 1995?
Your answer should be compact. 1.06. What is the ratio of the Total Labor Force (in %) of Ireland in 1994 to that in 1995?
Give a very brief answer. 0.98. What is the ratio of the Total Labor Force (in %) of Peru in 1994 to that in 1995?
Offer a terse response. 0.95. What is the ratio of the Total Labor Force (in %) in Congo (Democratic) in 1994 to that in 1996?
Give a very brief answer. 1. What is the ratio of the Total Labor Force (in %) of Ireland in 1994 to that in 1996?
Offer a very short reply. 0.95. What is the ratio of the Total Labor Force (in %) of Peru in 1994 to that in 1996?
Provide a short and direct response. 0.89. What is the ratio of the Total Labor Force (in %) of Egypt, Arab Rep. in 1994 to that in 1997?
Your answer should be very brief. 1.15. What is the ratio of the Total Labor Force (in %) of Ireland in 1994 to that in 1997?
Ensure brevity in your answer.  0.93. What is the ratio of the Total Labor Force (in %) in Peru in 1994 to that in 1997?
Your answer should be very brief. 0.84. What is the ratio of the Total Labor Force (in %) of Congo (Democratic) in 1994 to that in 1998?
Your response must be concise. 0.99. What is the ratio of the Total Labor Force (in %) in Egypt, Arab Rep. in 1994 to that in 1998?
Ensure brevity in your answer.  1.19. What is the ratio of the Total Labor Force (in %) in Ireland in 1994 to that in 1998?
Provide a short and direct response. 0.88. What is the ratio of the Total Labor Force (in %) in Peru in 1994 to that in 1998?
Your response must be concise. 0.83. What is the ratio of the Total Labor Force (in %) in Egypt, Arab Rep. in 1995 to that in 1996?
Provide a succinct answer. 1.03. What is the ratio of the Total Labor Force (in %) in Ireland in 1995 to that in 1996?
Give a very brief answer. 0.96. What is the ratio of the Total Labor Force (in %) in Peru in 1995 to that in 1996?
Provide a short and direct response. 0.94. What is the ratio of the Total Labor Force (in %) of Egypt, Arab Rep. in 1995 to that in 1997?
Offer a very short reply. 1.08. What is the ratio of the Total Labor Force (in %) of Ireland in 1995 to that in 1997?
Your answer should be very brief. 0.94. What is the ratio of the Total Labor Force (in %) of Peru in 1995 to that in 1997?
Your answer should be compact. 0.89. What is the ratio of the Total Labor Force (in %) of Congo (Democratic) in 1995 to that in 1998?
Provide a short and direct response. 0.99. What is the ratio of the Total Labor Force (in %) in Egypt, Arab Rep. in 1995 to that in 1998?
Provide a succinct answer. 1.12. What is the ratio of the Total Labor Force (in %) of Ireland in 1995 to that in 1998?
Your answer should be compact. 0.9. What is the ratio of the Total Labor Force (in %) of Peru in 1995 to that in 1998?
Offer a very short reply. 0.88. What is the ratio of the Total Labor Force (in %) of Egypt, Arab Rep. in 1996 to that in 1997?
Offer a terse response. 1.04. What is the ratio of the Total Labor Force (in %) in Ireland in 1996 to that in 1997?
Your response must be concise. 0.98. What is the ratio of the Total Labor Force (in %) of Peru in 1996 to that in 1997?
Ensure brevity in your answer.  0.94. What is the ratio of the Total Labor Force (in %) in Egypt, Arab Rep. in 1996 to that in 1998?
Provide a succinct answer. 1.08. What is the ratio of the Total Labor Force (in %) of Ireland in 1996 to that in 1998?
Keep it short and to the point. 0.93. What is the ratio of the Total Labor Force (in %) in Peru in 1996 to that in 1998?
Provide a short and direct response. 0.93. What is the ratio of the Total Labor Force (in %) of Egypt, Arab Rep. in 1997 to that in 1998?
Your answer should be compact. 1.04. What is the ratio of the Total Labor Force (in %) of Ireland in 1997 to that in 1998?
Provide a succinct answer. 0.95. What is the ratio of the Total Labor Force (in %) in Peru in 1997 to that in 1998?
Make the answer very short. 0.99. What is the difference between the highest and the second highest Total Labor Force (in %) of Congo (Democratic)?
Offer a very short reply. 0.1. What is the difference between the highest and the lowest Total Labor Force (in %) in Congo (Democratic)?
Keep it short and to the point. 2.2. What is the difference between the highest and the lowest Total Labor Force (in %) of Ireland?
Keep it short and to the point. 7.8. What is the difference between the highest and the lowest Total Labor Force (in %) of Peru?
Keep it short and to the point. 14.3. 